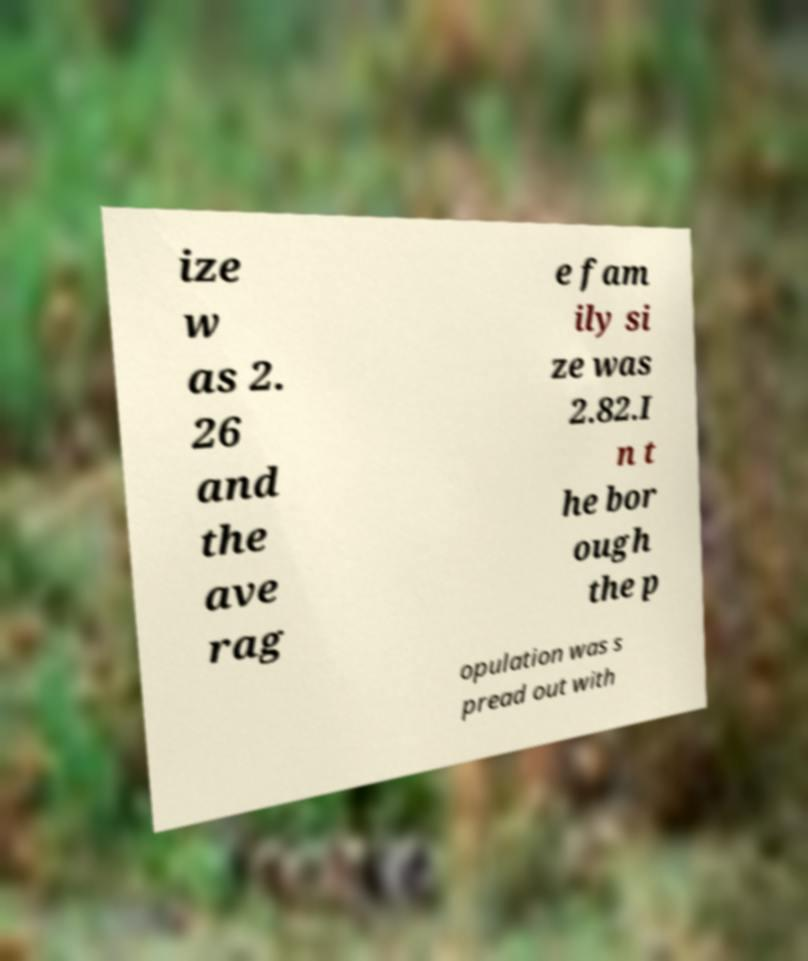Please read and relay the text visible in this image. What does it say? ize w as 2. 26 and the ave rag e fam ily si ze was 2.82.I n t he bor ough the p opulation was s pread out with 